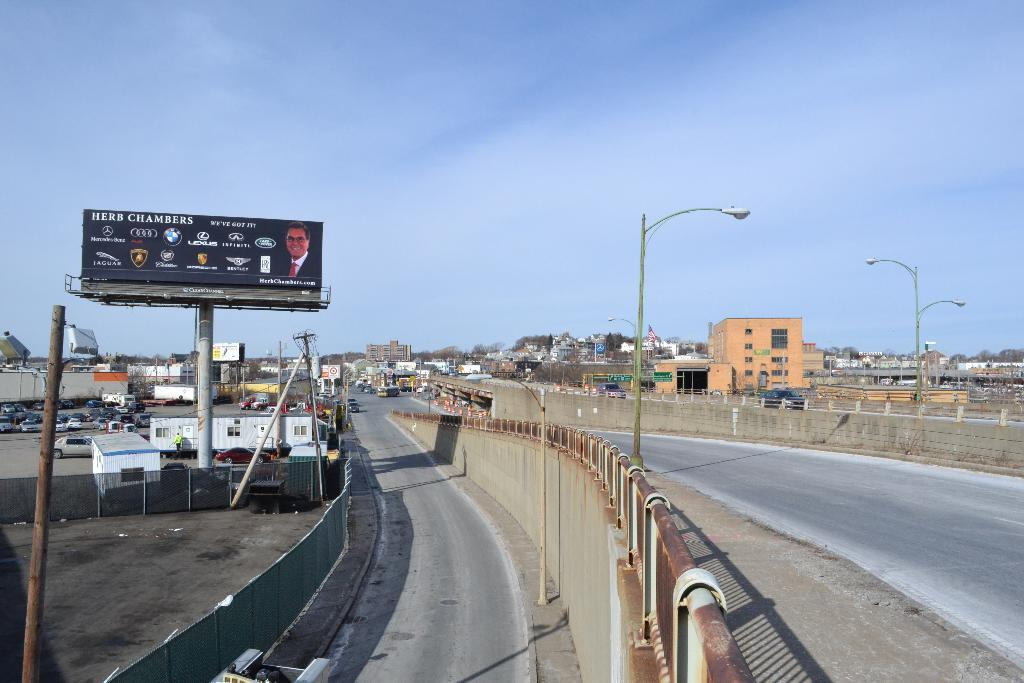<image>
Summarize the visual content of the image. A highway scene including a billboard for Herb Chambers' auto dealership. 